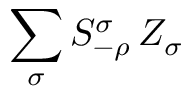Convert formula to latex. <formula><loc_0><loc_0><loc_500><loc_500>\sum _ { \sigma } S _ { - \rho } ^ { \sigma } \, Z _ { \sigma }</formula> 